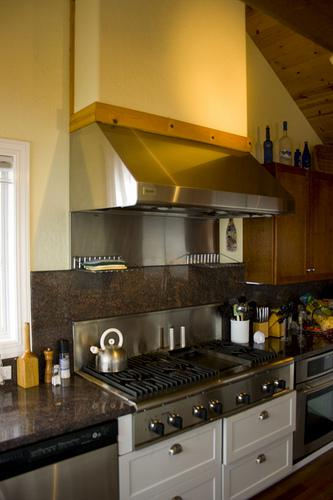Question: why is the stove off?
Choices:
A. Not in use.
B. It doesn't work.
C. It's unplugged.
D. The gas is off.
Answer with the letter. Answer: A Question: what is black?
Choices:
A. The snake.
B. The man's car.
C. Countertops.
D. The boots.
Answer with the letter. Answer: C 